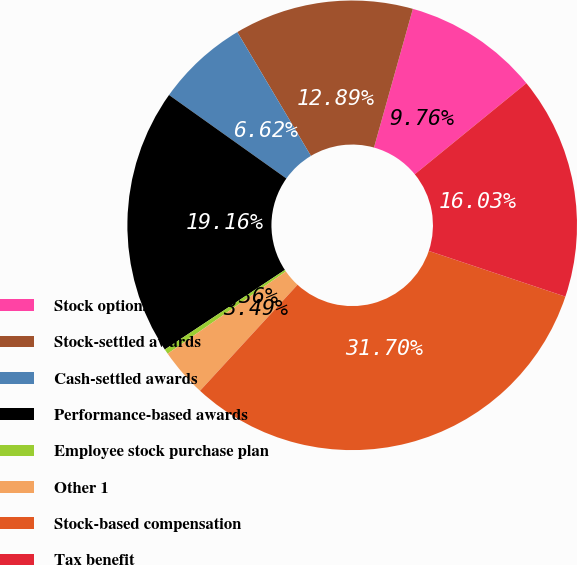Convert chart. <chart><loc_0><loc_0><loc_500><loc_500><pie_chart><fcel>Stock options<fcel>Stock-settled awards<fcel>Cash-settled awards<fcel>Performance-based awards<fcel>Employee stock purchase plan<fcel>Other 1<fcel>Stock-based compensation<fcel>Tax benefit<nl><fcel>9.76%<fcel>12.89%<fcel>6.62%<fcel>19.16%<fcel>0.36%<fcel>3.49%<fcel>31.7%<fcel>16.03%<nl></chart> 